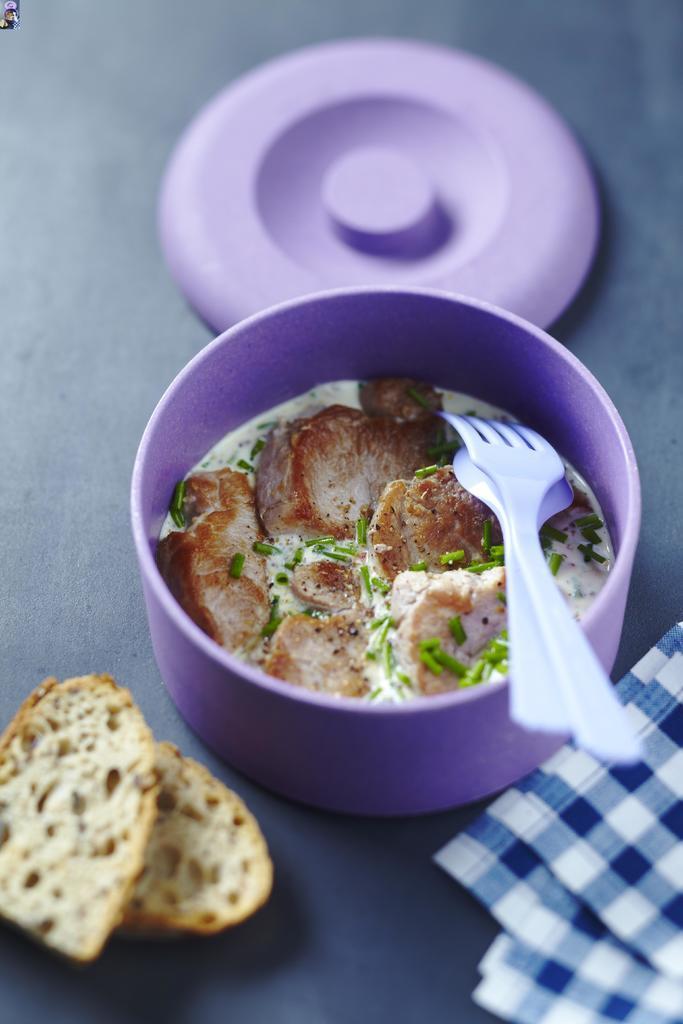Could you give a brief overview of what you see in this image? In this image I can see a blue colored surface on which I can see a cloth which is blue and white in color, few bread slices and a bowl which is violet in color. In the bowl I can see a food item which is brown, white and green in color, a spoon and a fork. I can see a lid of the bowl. 